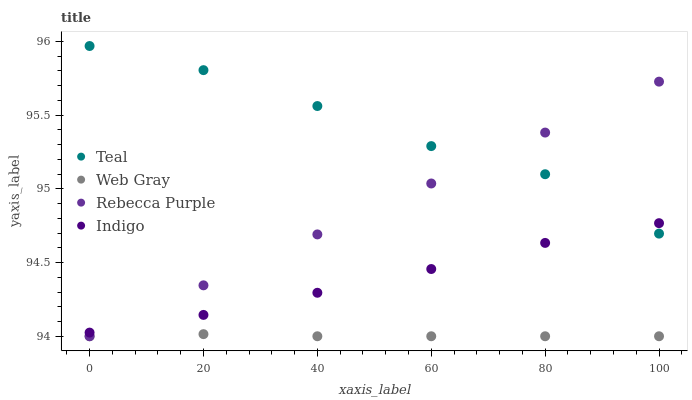Does Web Gray have the minimum area under the curve?
Answer yes or no. Yes. Does Teal have the maximum area under the curve?
Answer yes or no. Yes. Does Indigo have the minimum area under the curve?
Answer yes or no. No. Does Indigo have the maximum area under the curve?
Answer yes or no. No. Is Rebecca Purple the smoothest?
Answer yes or no. Yes. Is Teal the roughest?
Answer yes or no. Yes. Is Indigo the smoothest?
Answer yes or no. No. Is Indigo the roughest?
Answer yes or no. No. Does Web Gray have the lowest value?
Answer yes or no. Yes. Does Indigo have the lowest value?
Answer yes or no. No. Does Teal have the highest value?
Answer yes or no. Yes. Does Indigo have the highest value?
Answer yes or no. No. Is Web Gray less than Teal?
Answer yes or no. Yes. Is Indigo greater than Web Gray?
Answer yes or no. Yes. Does Indigo intersect Teal?
Answer yes or no. Yes. Is Indigo less than Teal?
Answer yes or no. No. Is Indigo greater than Teal?
Answer yes or no. No. Does Web Gray intersect Teal?
Answer yes or no. No. 